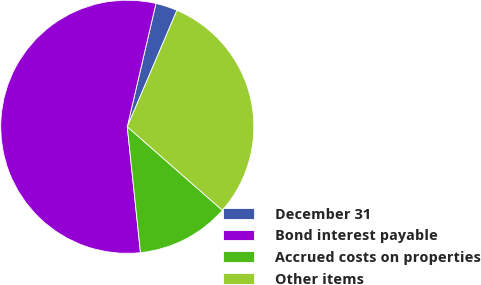<chart> <loc_0><loc_0><loc_500><loc_500><pie_chart><fcel>December 31<fcel>Bond interest payable<fcel>Accrued costs on properties<fcel>Other items<nl><fcel>2.78%<fcel>55.3%<fcel>11.87%<fcel>30.05%<nl></chart> 